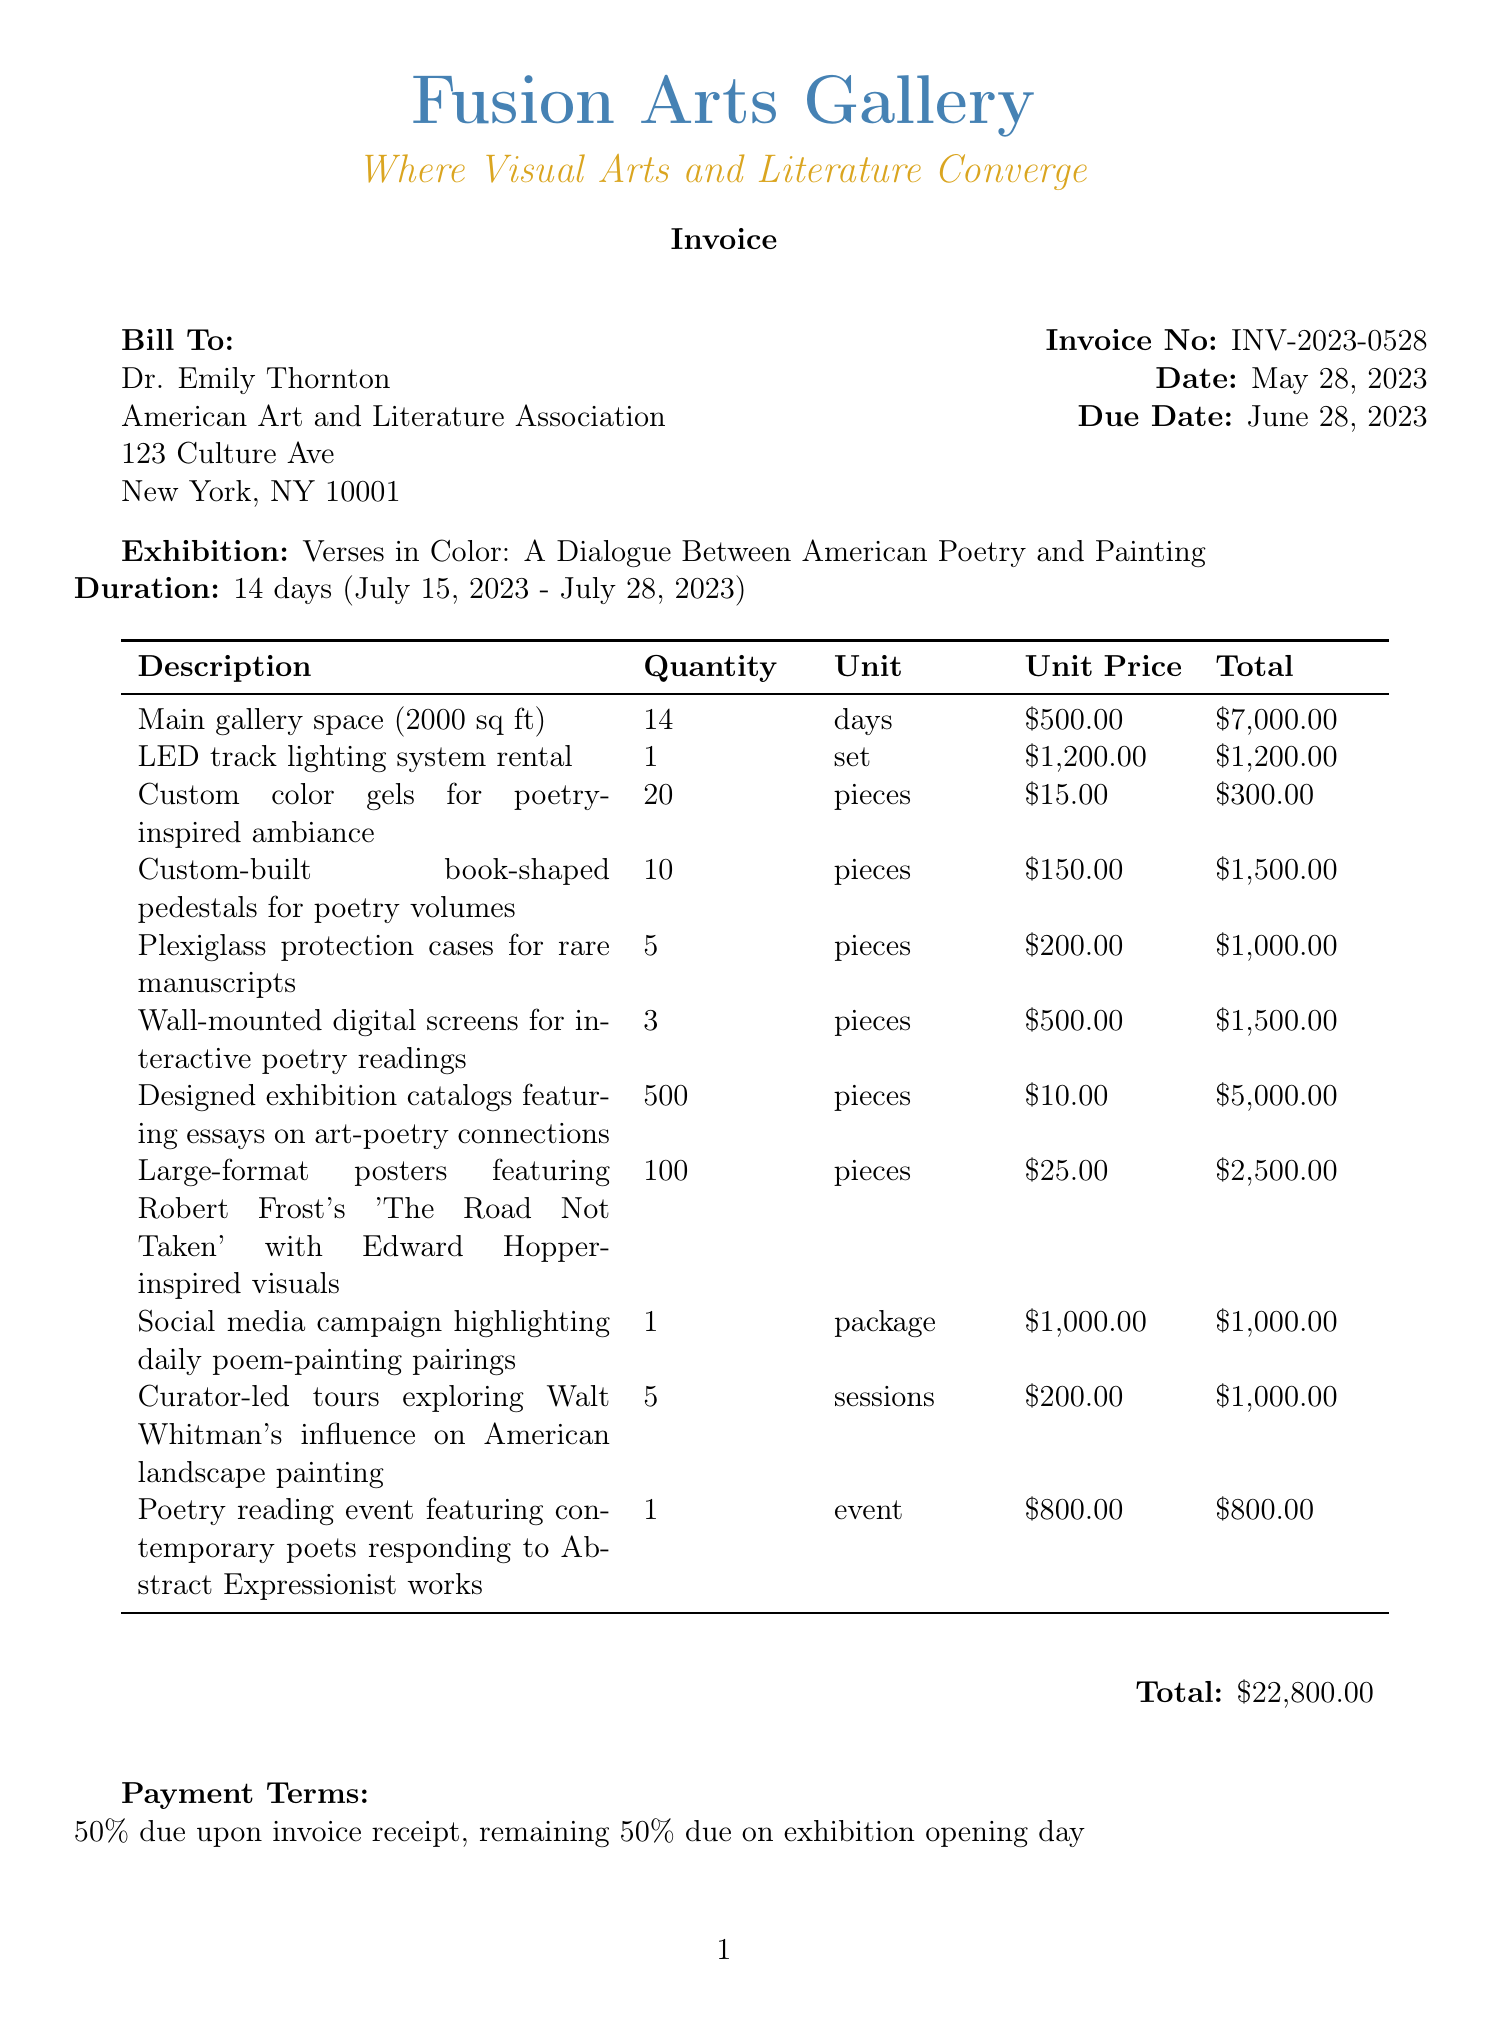What is the invoice number? The invoice number is a unique identifier for the document.
Answer: INV-2023-0528 Who is the bill to? The "Bill To" section provides the name of the client being invoiced.
Answer: Dr. Emily Thornton What is the total cost? The total cost sums up all itemized expenses listed in the invoice.
Answer: $22,800.00 What is the exhibition title? The title of the exhibition is mentioned prominently in the document.
Answer: Verses in Color: A Dialogue Between American Poetry and Painting How many days is the exhibition duration? The duration of the exhibition specifies how long it will be held.
Answer: 14 days What type of promotional materials will be used? This question involves identifying the kind of materials listed in the invoice related to promotions.
Answer: Exhibition catalogs What date is the invoice due? The due date indicates when payment for the invoice is expected.
Answer: June 28, 2023 How many sessions are there for curator-led tours? The number of sessions is specified in detail within the services section.
Answer: 5 sessions What services are included in the invoice? This requires understanding the range of services listed that go beyond basic rental costs.
Answer: Curator-led tours, Poetry reading event 